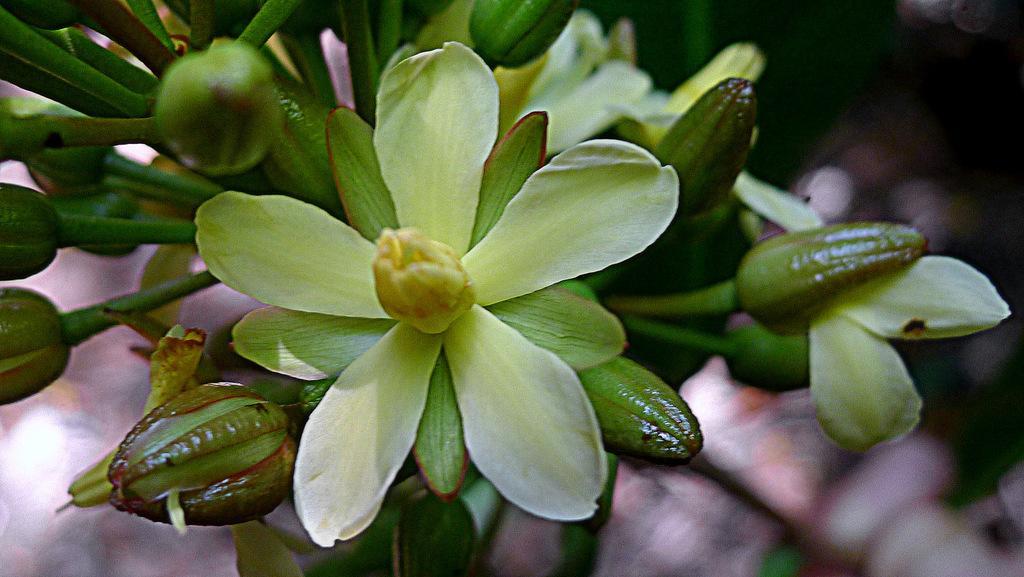Please provide a concise description of this image. In this image, we can see some flowers, buds and the background is blurred. 